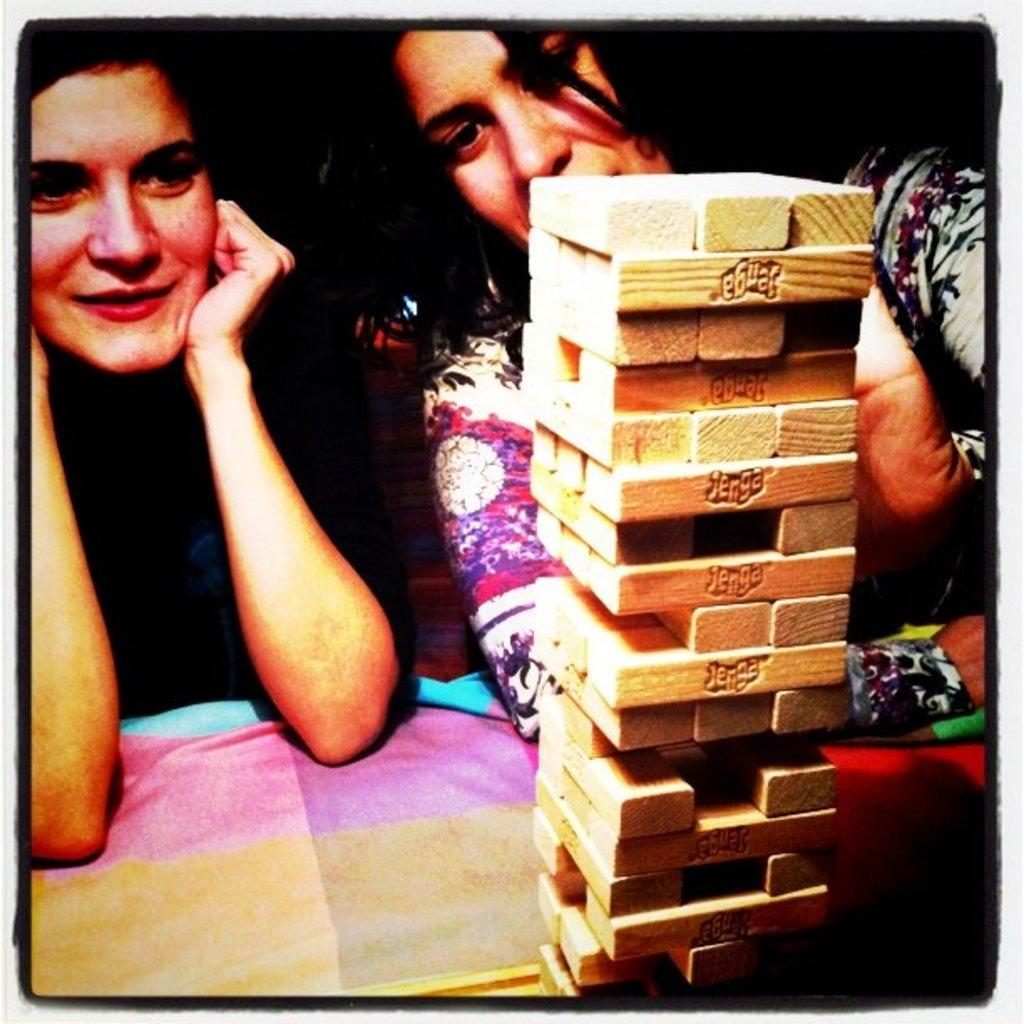How many women are in the image? There are two women in the center of the image. What is located at the bottom of the image? There is a bed at the bottom of the image. What can be seen in the foreground of the image? There are wooden sticks in the foreground of the image. What type of riddle can be solved by the women in the image? There is no riddle present in the image, nor is there any indication that the women are solving a riddle. Can you tell me how many balls of yarn are on the bed in the image? There is no yarn present in the image, so it is not possible to determine the number of balls of yarn on the bed. 